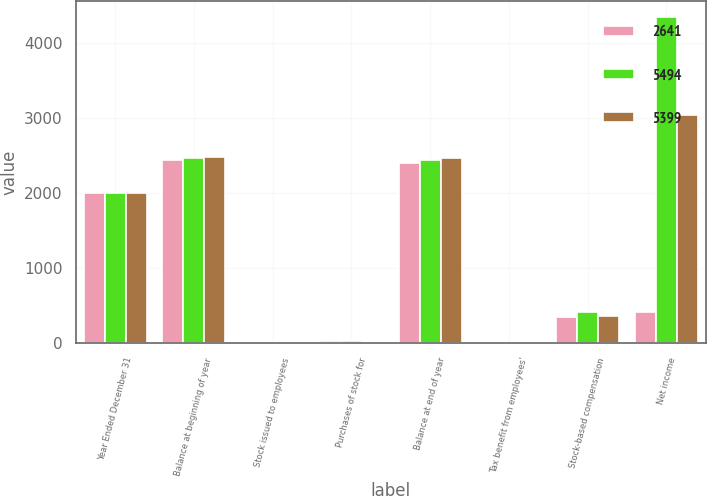Convert chart. <chart><loc_0><loc_0><loc_500><loc_500><stacked_bar_chart><ecel><fcel>Year Ended December 31<fcel>Balance at beginning of year<fcel>Stock issued to employees<fcel>Purchases of stock for<fcel>Balance at end of year<fcel>Tax benefit from employees'<fcel>Stock-based compensation<fcel>Net income<nl><fcel>2641<fcel>2004<fcel>2442<fcel>5<fcel>38<fcel>2409<fcel>13<fcel>345<fcel>422<nl><fcel>5494<fcel>2003<fcel>2471<fcel>4<fcel>33<fcel>2442<fcel>11<fcel>422<fcel>4347<nl><fcel>5399<fcel>2002<fcel>2486<fcel>3<fcel>14<fcel>2471<fcel>11<fcel>365<fcel>3050<nl></chart> 